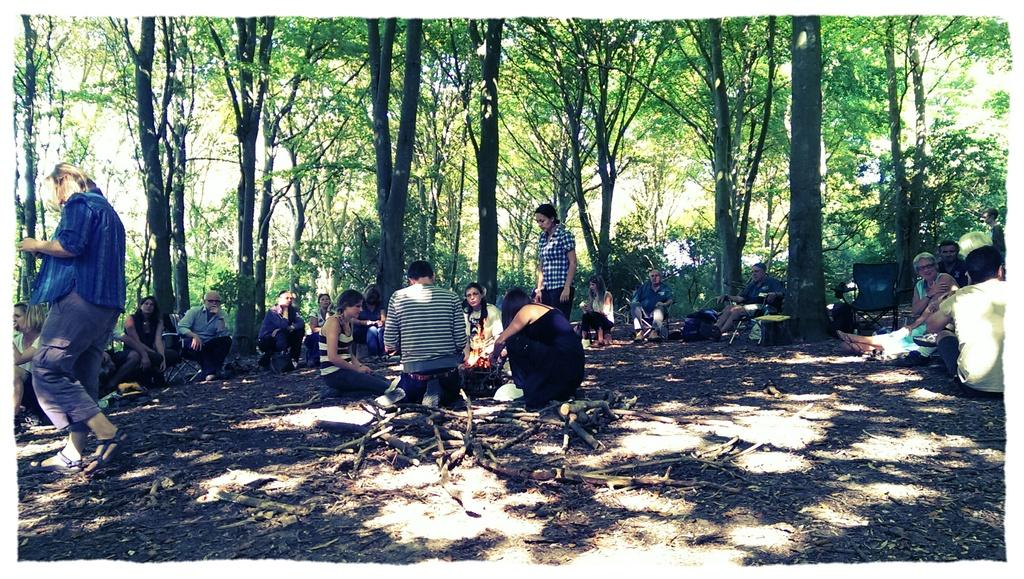What is the setting of the image? The image is set in an area between a forest. What are the people in the image doing? There are people sitting on the ground, and a group of people at the center of the image is lighting a fire. What type of tomatoes are being used to force the people to feel shame in the image? There is no mention of tomatoes, force, or shame in the image. The image shows people sitting on the ground and lighting a fire. 